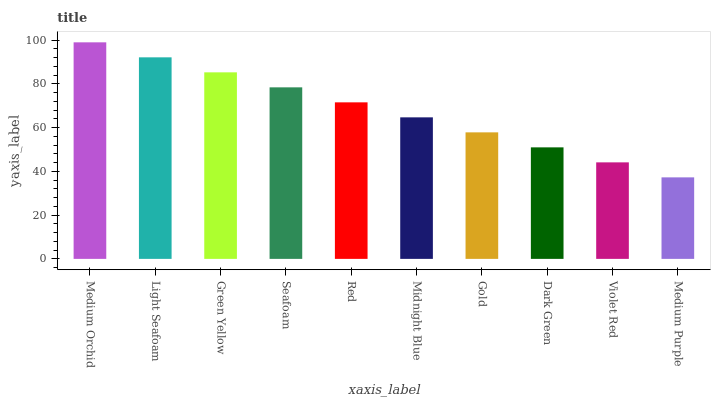Is Medium Purple the minimum?
Answer yes or no. Yes. Is Medium Orchid the maximum?
Answer yes or no. Yes. Is Light Seafoam the minimum?
Answer yes or no. No. Is Light Seafoam the maximum?
Answer yes or no. No. Is Medium Orchid greater than Light Seafoam?
Answer yes or no. Yes. Is Light Seafoam less than Medium Orchid?
Answer yes or no. Yes. Is Light Seafoam greater than Medium Orchid?
Answer yes or no. No. Is Medium Orchid less than Light Seafoam?
Answer yes or no. No. Is Red the high median?
Answer yes or no. Yes. Is Midnight Blue the low median?
Answer yes or no. Yes. Is Dark Green the high median?
Answer yes or no. No. Is Red the low median?
Answer yes or no. No. 